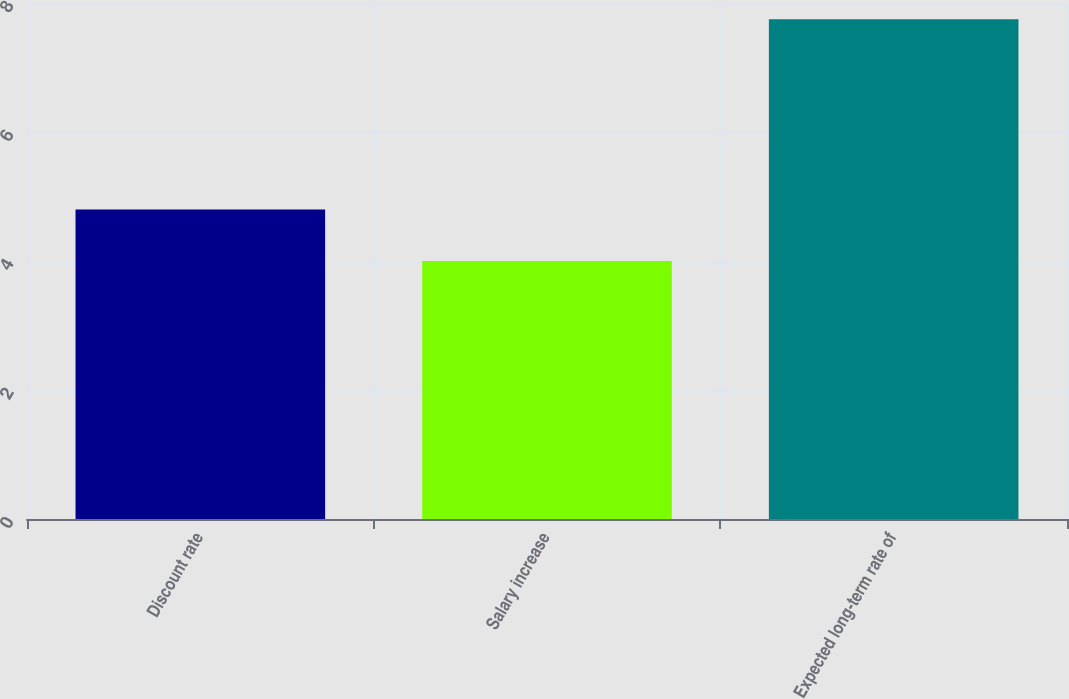<chart> <loc_0><loc_0><loc_500><loc_500><bar_chart><fcel>Discount rate<fcel>Salary increase<fcel>Expected long-term rate of<nl><fcel>4.8<fcel>4<fcel>7.75<nl></chart> 